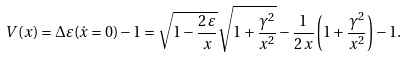Convert formula to latex. <formula><loc_0><loc_0><loc_500><loc_500>V ( x ) = \Delta \varepsilon ( \dot { x } = 0 ) - 1 = \sqrt { 1 - \frac { 2 \, \varepsilon } { x } } \sqrt { 1 + \frac { \gamma ^ { 2 } } { x ^ { 2 } } } - \frac { 1 } { 2 \, x } \left ( 1 + \frac { \gamma ^ { 2 } } { x ^ { 2 } } \right ) - 1 .</formula> 